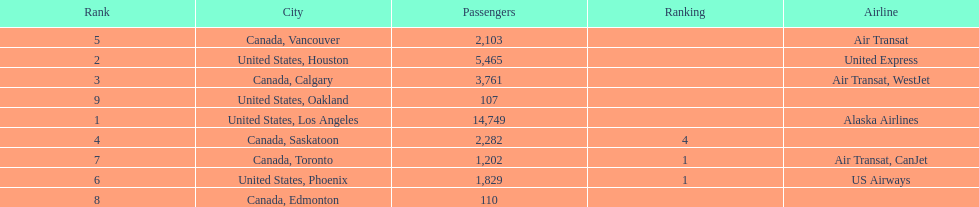Which airline carries the most passengers? Alaska Airlines. 